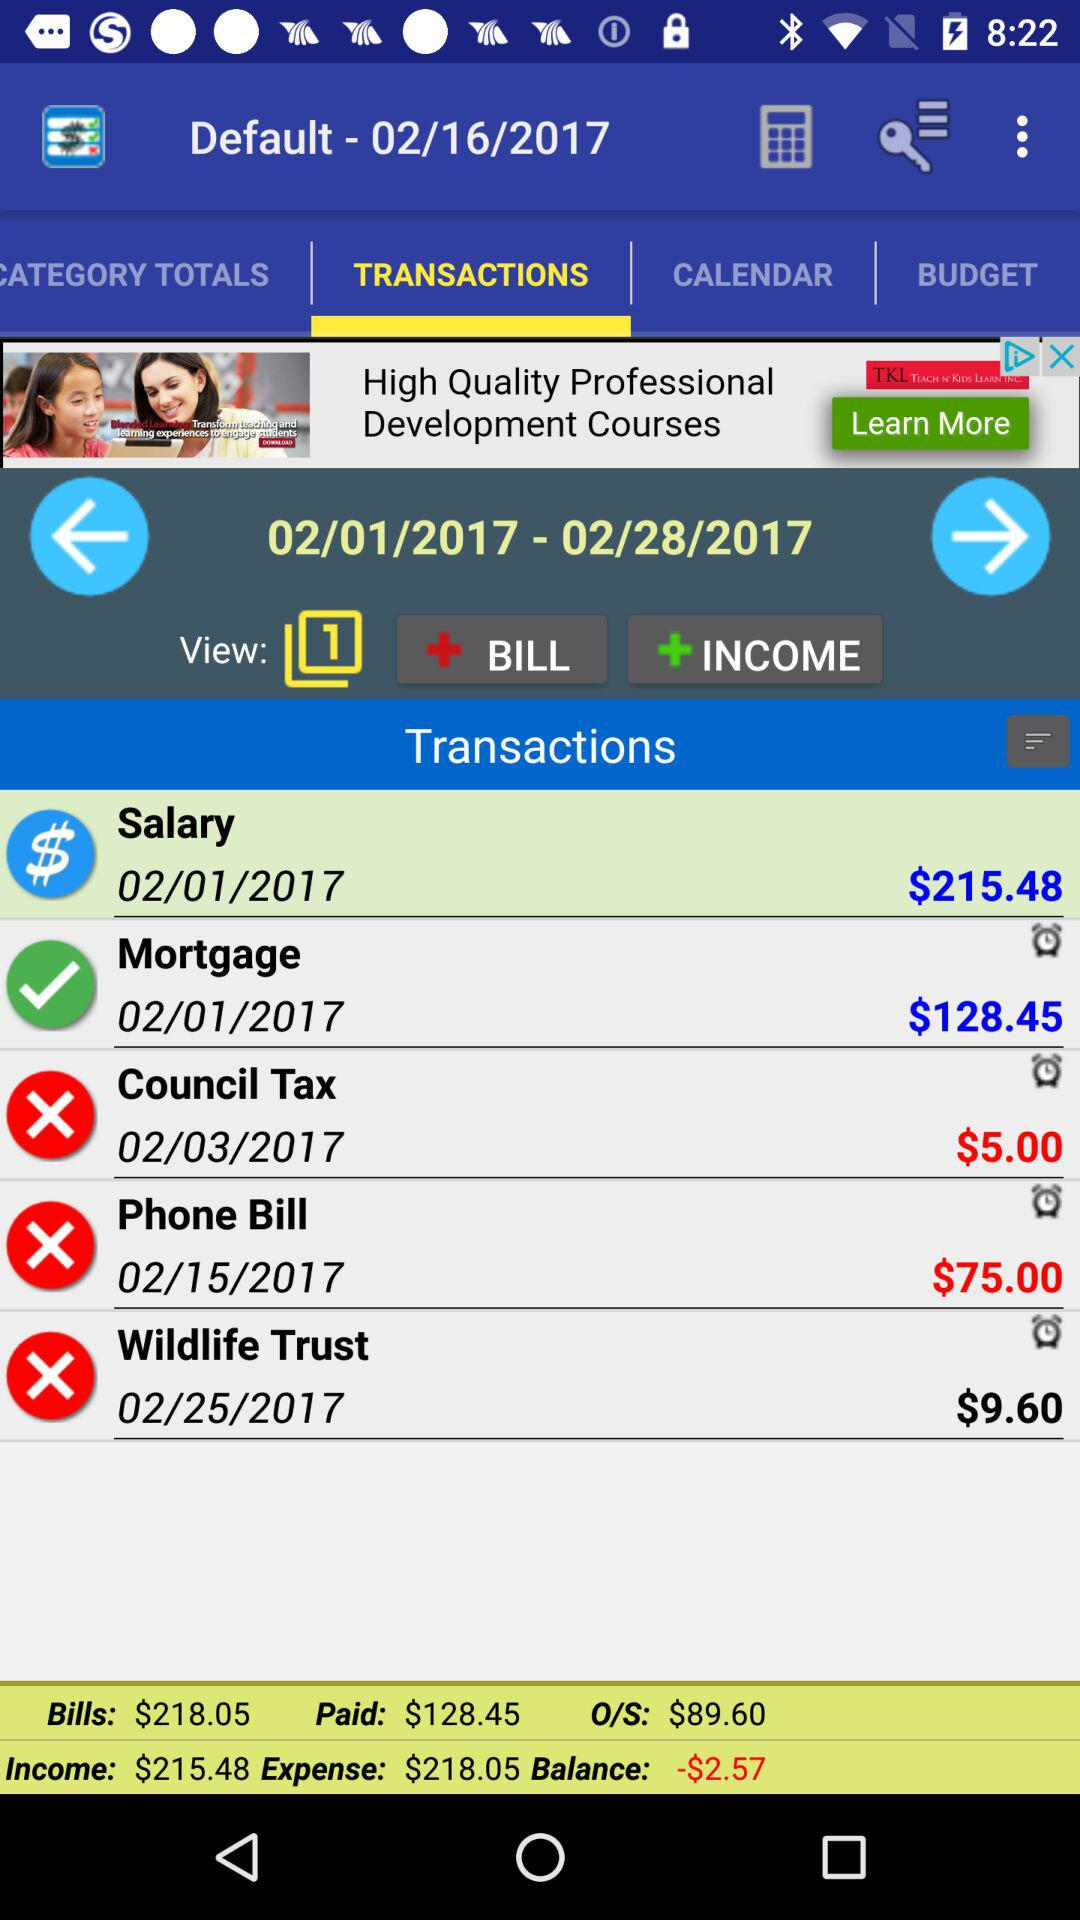What is the total amount of money spent on bills and income?
Answer the question using a single word or phrase. $218.05 